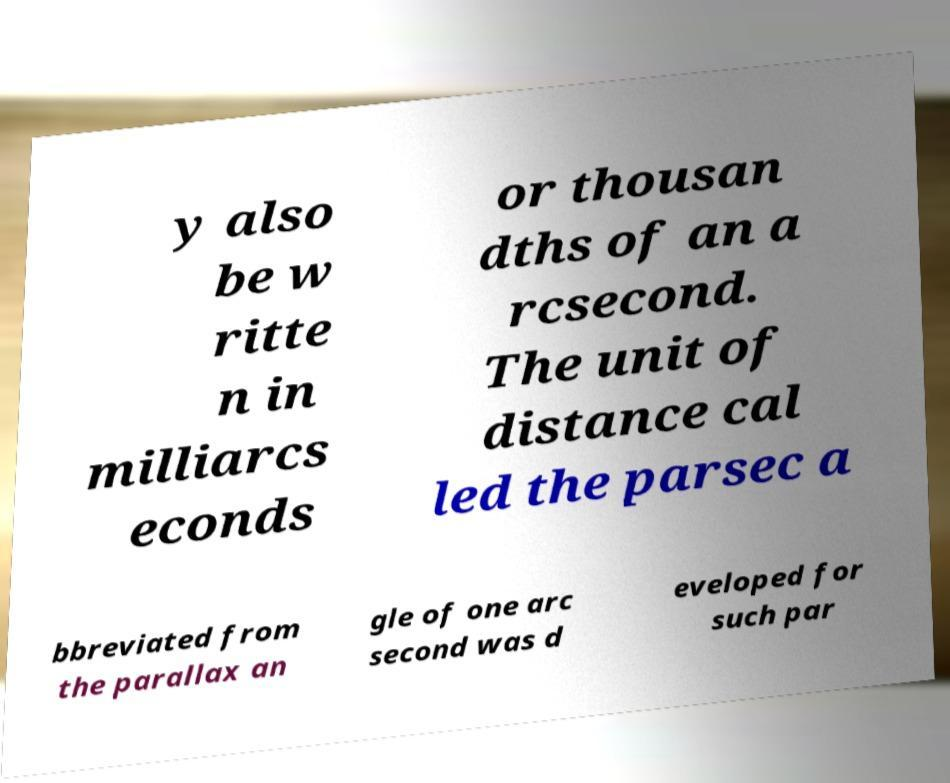Please identify and transcribe the text found in this image. y also be w ritte n in milliarcs econds or thousan dths of an a rcsecond. The unit of distance cal led the parsec a bbreviated from the parallax an gle of one arc second was d eveloped for such par 